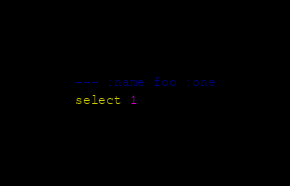<code> <loc_0><loc_0><loc_500><loc_500><_SQL_>--- :name foo :one
select 1
</code> 